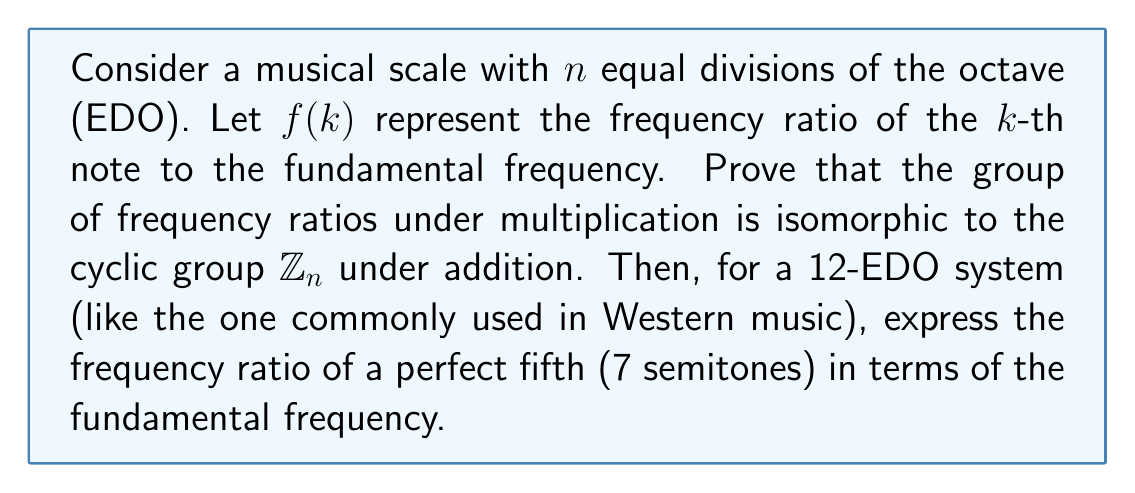What is the answer to this math problem? Let's approach this step-by-step:

1) In an $n$-EDO system, the frequency ratio for the $k$-th note is given by:

   $f(k) = 2^{k/n}$

2) The group operation for frequency ratios is multiplication. For any two notes $k$ and $m$:

   $f(k) \cdot f(m) = 2^{k/n} \cdot 2^{m/n} = 2^{(k+m)/n} = f(k+m)$

3) This operation is closed and associative. The identity element is $f(0) = 2^0 = 1$, and the inverse of $f(k)$ is $f(-k)$.

4) We can define a mapping $\phi$ from the group of frequency ratios to $\mathbb{Z}_n$ as:

   $\phi: f(k) \mapsto k \mod n$

5) This mapping is a homomorphism because:

   $\phi(f(k) \cdot f(m)) = \phi(f(k+m)) = (k+m) \mod n = (k \mod n + m \mod n) \mod n$

6) The mapping is also bijective: it's surjective because every element in $\mathbb{Z}_n$ is the image of some $f(k)$, and it's injective because if $\phi(f(k)) = \phi(f(m))$, then $k \equiv m \pmod{n}$, which implies $f(k) = f(m)$.

7) Therefore, the group of frequency ratios is isomorphic to $\mathbb{Z}_n$.

8) For a 12-EDO system, a perfect fifth is 7 semitones above the fundamental. So its frequency ratio is:

   $f(7) = 2^{7/12}$

This ratio is approximately 1.4983, which is close to the just intonation ratio of 3:2 for a perfect fifth.
Answer: The group of frequency ratios in an $n$-EDO system is isomorphic to $\mathbb{Z}_n$. In a 12-EDO system, the frequency ratio of a perfect fifth is $2^{7/12}$. 